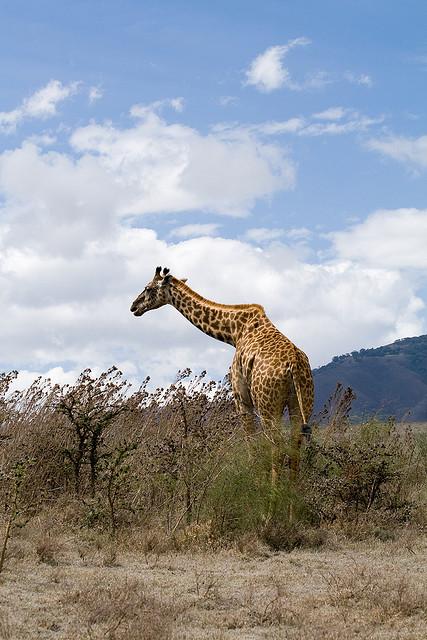Is this giraffe in a zoo?
Write a very short answer. No. What color is the giraffe?
Keep it brief. Yellow and brown. Are there are lot of clouds?
Short answer required. Yes. 